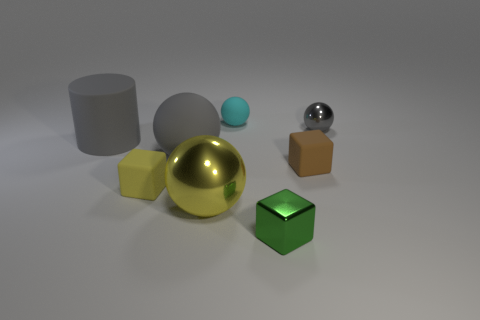How many tiny yellow rubber cubes are there?
Make the answer very short. 1. There is a gray sphere on the left side of the small cyan matte object; what is it made of?
Provide a short and direct response. Rubber. Are there any small cubes to the left of the tiny metal cube?
Your response must be concise. Yes. Does the brown rubber thing have the same size as the yellow shiny object?
Provide a succinct answer. No. What number of balls are the same material as the brown thing?
Ensure brevity in your answer.  2. There is a green thing that is on the right side of the large ball behind the brown matte thing; what is its size?
Make the answer very short. Small. The sphere that is both in front of the gray matte cylinder and to the right of the large gray rubber sphere is what color?
Keep it short and to the point. Yellow. Do the tiny gray shiny thing and the cyan object have the same shape?
Your answer should be compact. Yes. What size is the rubber block that is the same color as the big metallic ball?
Your response must be concise. Small. There is a tiny metal object that is to the left of the small ball that is in front of the small cyan thing; what shape is it?
Provide a short and direct response. Cube. 